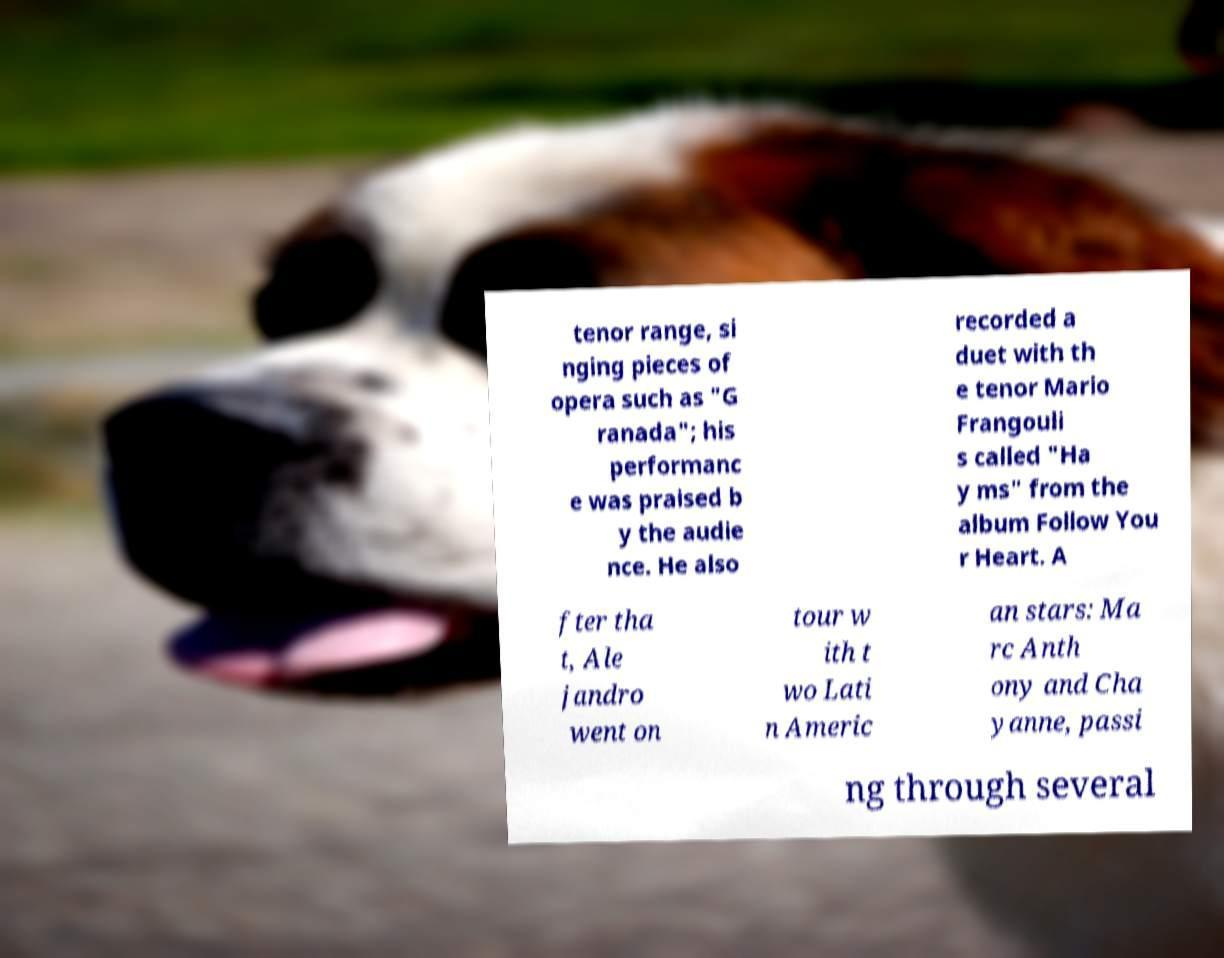Could you extract and type out the text from this image? tenor range, si nging pieces of opera such as "G ranada"; his performanc e was praised b y the audie nce. He also recorded a duet with th e tenor Mario Frangouli s called "Ha y ms" from the album Follow You r Heart. A fter tha t, Ale jandro went on tour w ith t wo Lati n Americ an stars: Ma rc Anth ony and Cha yanne, passi ng through several 